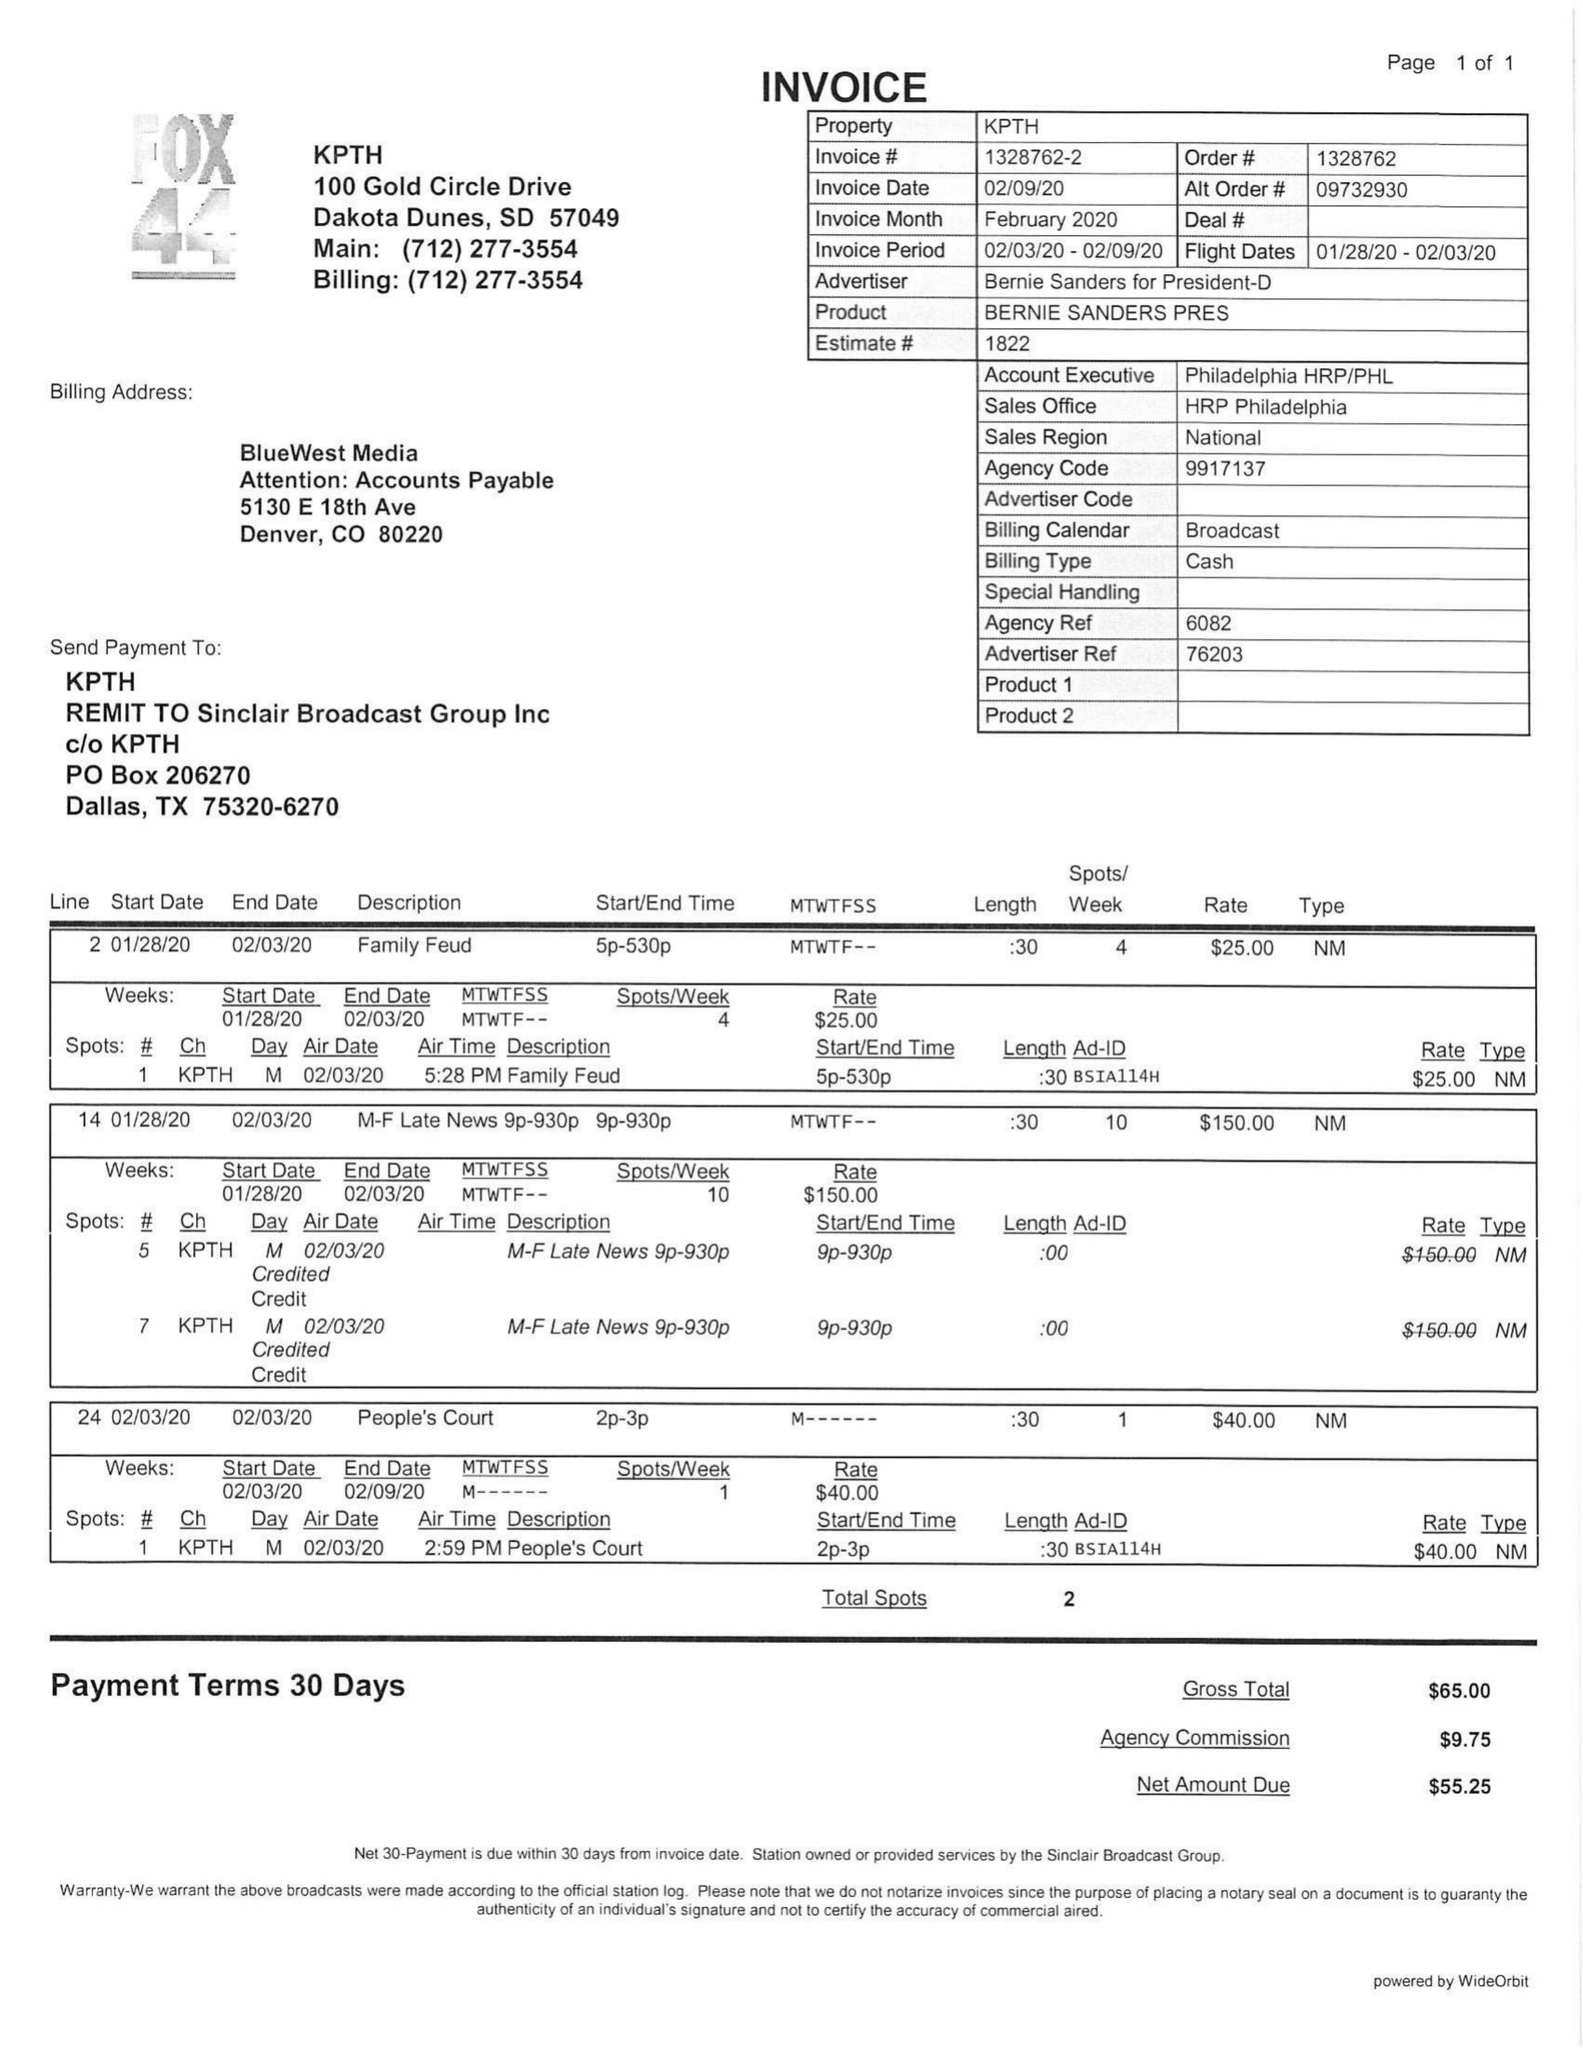What is the value for the flight_to?
Answer the question using a single word or phrase. 02/03/20 